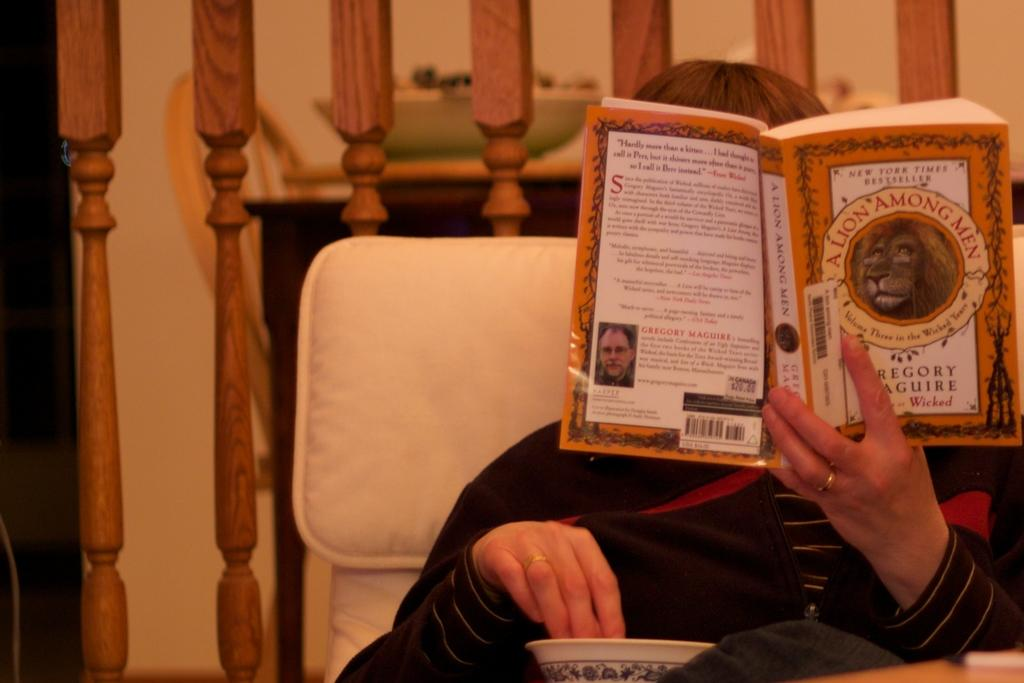<image>
Write a terse but informative summary of the picture. The young boy reads the novel "A Lion Among Men" as he enjoys his popcorn. 